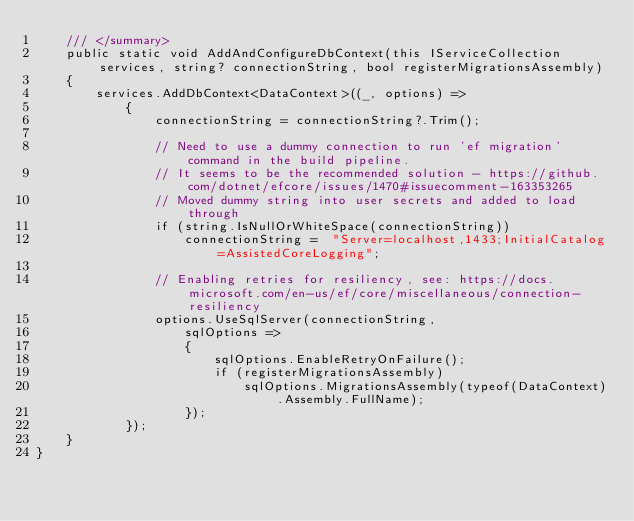<code> <loc_0><loc_0><loc_500><loc_500><_C#_>	/// </summary>
	public static void AddAndConfigureDbContext(this IServiceCollection services, string? connectionString, bool registerMigrationsAssembly)
	{
		services.AddDbContext<DataContext>((_, options) =>
			{
				connectionString = connectionString?.Trim();

				// Need to use a dummy connection to run 'ef migration' command in the build pipeline.
				// It seems to be the recommended solution - https://github.com/dotnet/efcore/issues/1470#issuecomment-163353265
				// Moved dummy string into user secrets and added to load through
				if (string.IsNullOrWhiteSpace(connectionString))
					connectionString =  "Server=localhost,1433;InitialCatalog=AssistedCoreLogging";

				// Enabling retries for resiliency, see: https://docs.microsoft.com/en-us/ef/core/miscellaneous/connection-resiliency
				options.UseSqlServer(connectionString,
					sqlOptions =>
					{
						sqlOptions.EnableRetryOnFailure();
						if (registerMigrationsAssembly)
							sqlOptions.MigrationsAssembly(typeof(DataContext).Assembly.FullName);
					});
			});
	}
}
</code> 